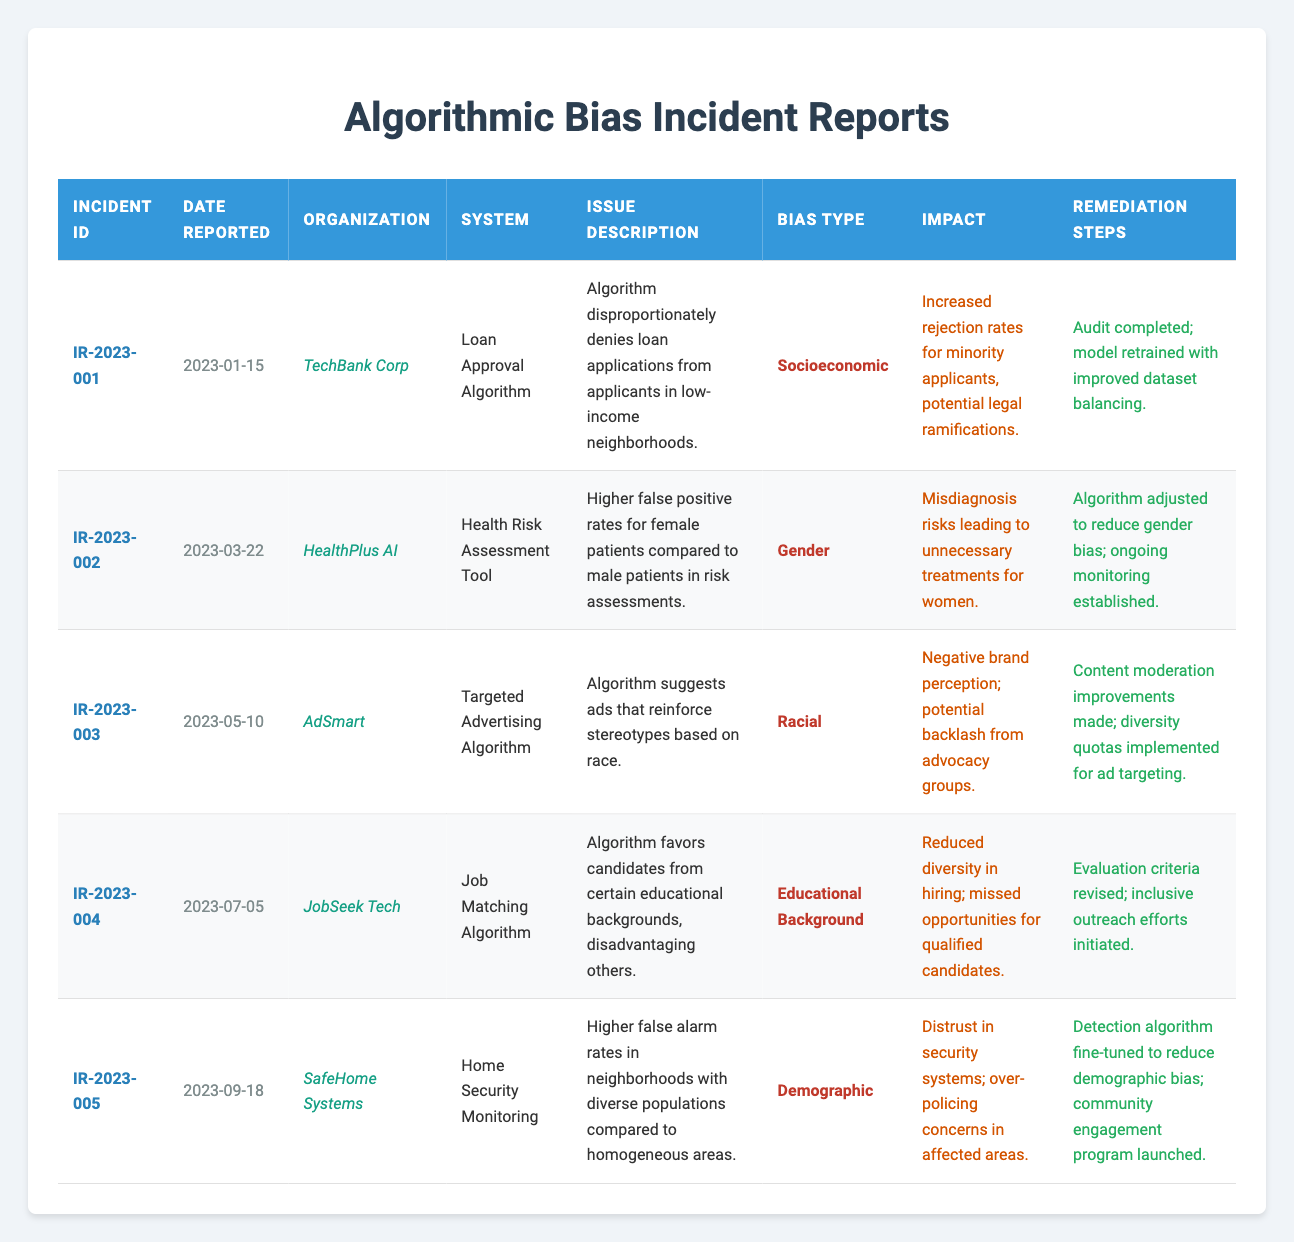What is the incident ID for the report made by TechBank Corp? The table shows that the incident ID associated with TechBank Corp is listed under that organization's row, which is IR-2023-001.
Answer: IR-2023-001 Which organization reported an issue related to gender bias? In the table, the organization that reported an issue related to gender bias can be found by looking at the bias type column. The row corresponding to HealthPlus AI indicates the incident involving higher false positive rates for female patients.
Answer: HealthPlus AI How many incidents reported involved racial bias? To determine this, I check the bias type column and count the occurrences of "Racial." In the table, the entry from AdSmart is the only one indicating racial bias, thus there is only one such incident.
Answer: 1 Did SafeHome Systems report an incident related to socioeconomic bias? Looking at the bias type for the incident reported by SafeHome Systems, which deals with demographic bias, we find that it does not indicate socioeconomic bias, confirming the answer is no.
Answer: No What are the remediation steps taken after the incident reported on 2023-05-10? I locate the row corresponding to the incident reported on 2023-05-10, which is associated with AdSmart. The remediation steps listed in that row detail content moderation improvements and the implementation of diversity quotas for ad targeting.
Answer: Content moderation improvements made; diversity quotas implemented for ad targeting What is the impact of the incident related to JobSeek Tech's algorithm? To find the impact, I refer to the JobMatch algorithm row. The impact described indicates reduced diversity in hiring and missed opportunities for qualified candidates, which are the consequences of the identified bias.
Answer: Reduced diversity in hiring; missed opportunities for qualified candidates Which bias type affected the Loan Approval Algorithm? The bias type column for the incident under the Loan Approval Algorithm shows it has socioeconomic bias as noted in the description of the issue.
Answer: Socioeconomic Was there any incident reported on 2023-09-18? Yes, by checking the date reported column, I can confirm that SafeHome Systems reported an incident on that date listed in the table.
Answer: Yes How many different types of bias were reported across all incidents? To find the number of unique bias types, I review the bias type column and list each distinct bias: socioeconomic, gender, racial, educational background, and demographic. That's a total of five unique bias types across the incidents.
Answer: 5 What steps were taken to remediate the issue of higher false positives for women? Referring to the incident reported by HealthPlus AI regarding gender bias, the remediation steps state that the algorithm was adjusted to reduce gender bias and an ongoing monitoring process was established to keep track of its performance.
Answer: Algorithm adjusted to reduce gender bias; ongoing monitoring established 